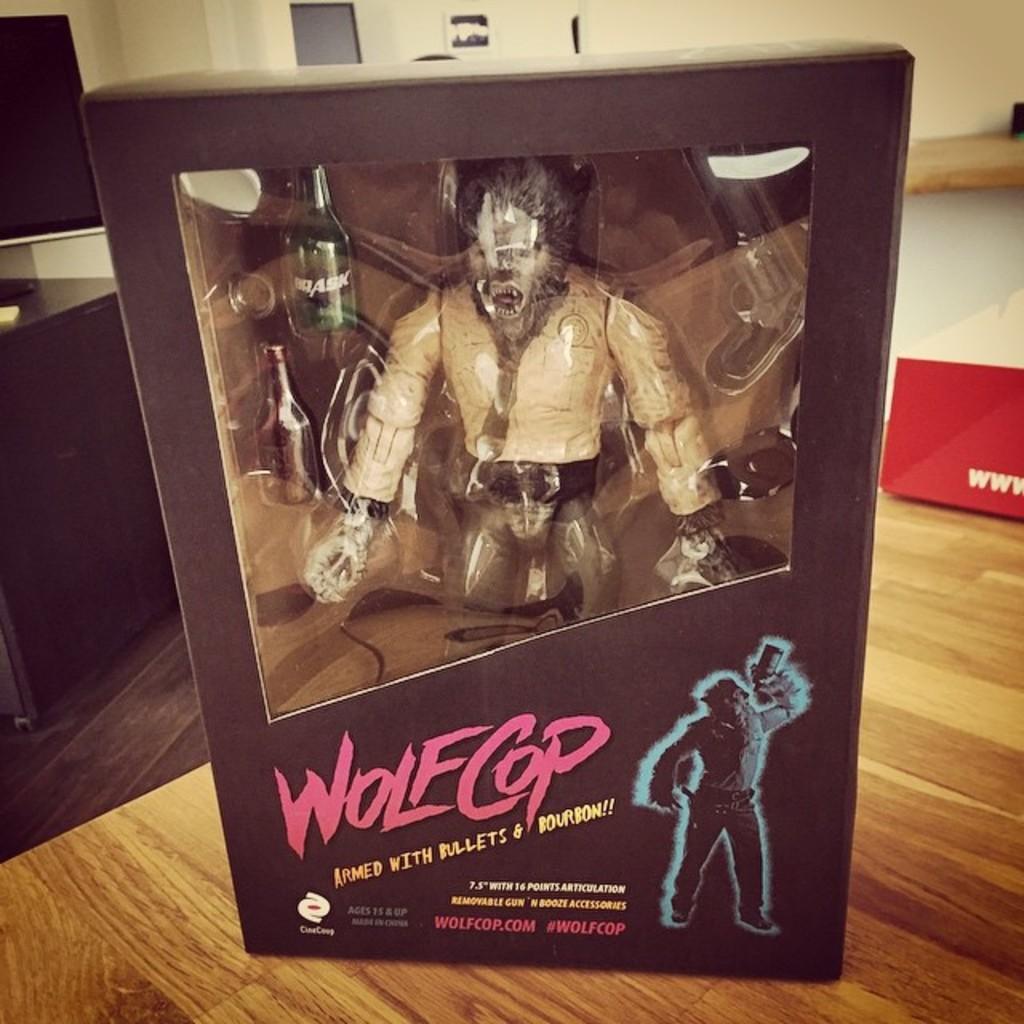What action figure is this?
Your response must be concise. Wolf cop. Wolfcop is armed with bullets and what?
Ensure brevity in your answer.  Bourbon. 